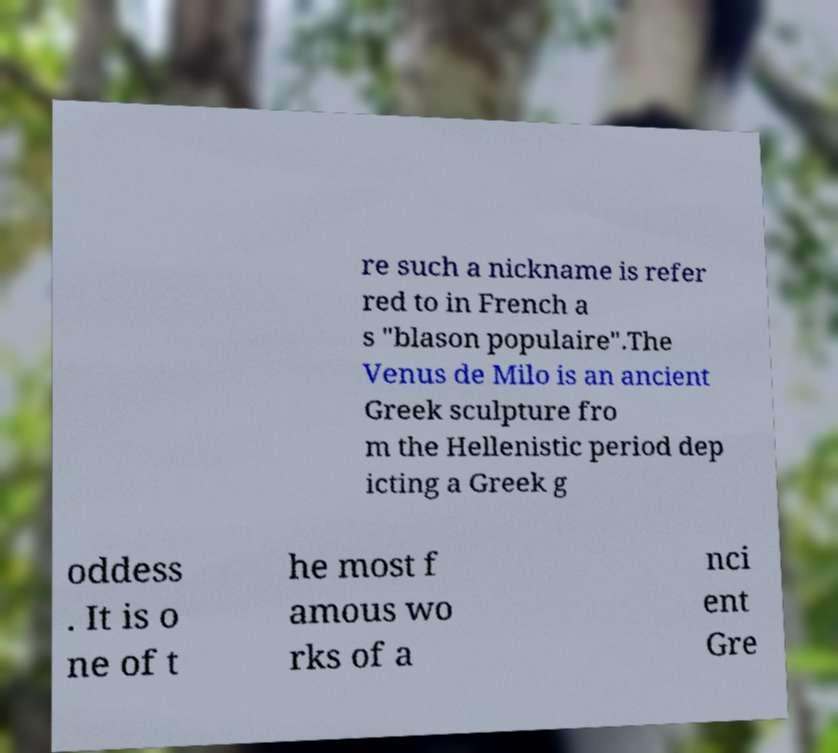There's text embedded in this image that I need extracted. Can you transcribe it verbatim? re such a nickname is refer red to in French a s "blason populaire".The Venus de Milo is an ancient Greek sculpture fro m the Hellenistic period dep icting a Greek g oddess . It is o ne of t he most f amous wo rks of a nci ent Gre 